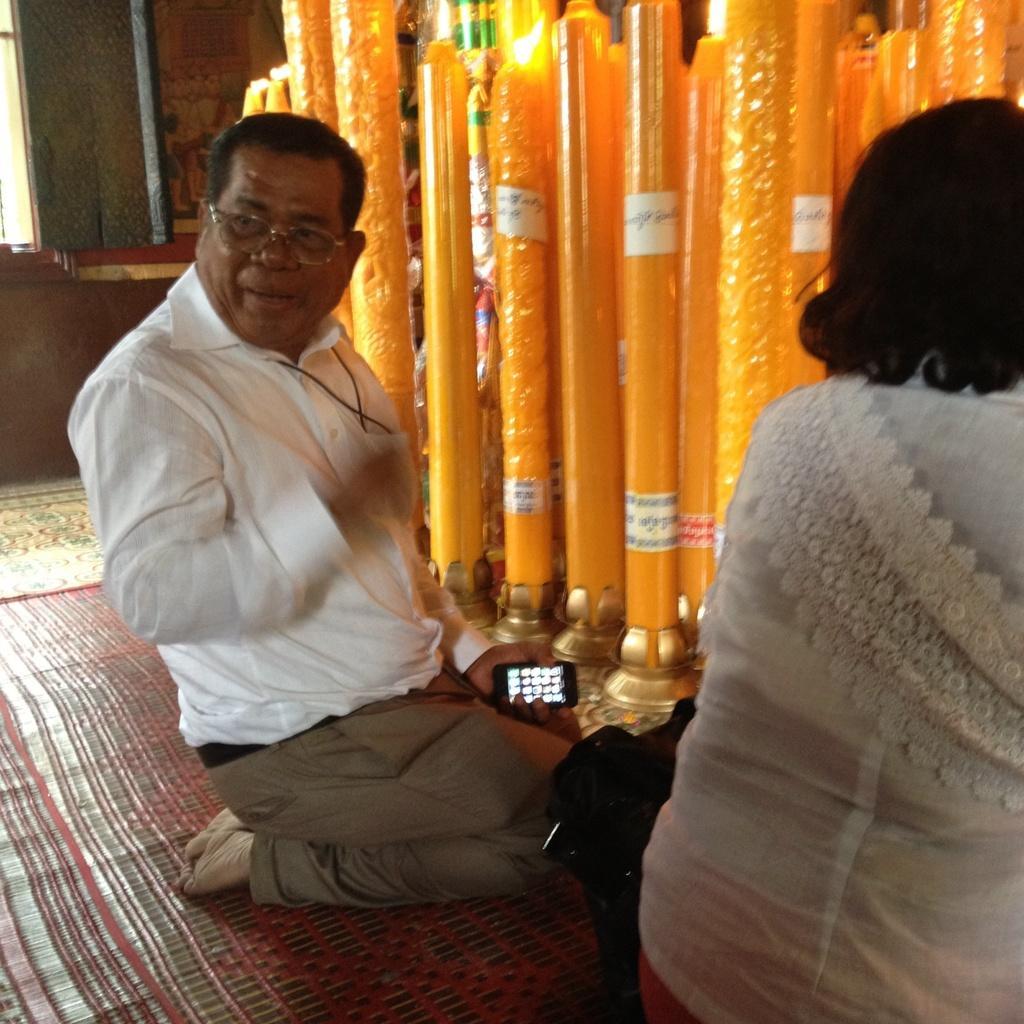Could you give a brief overview of what you see in this image? In this image we can see a person sitting on his knees holding a cellphone. We can also see a woman beside him. On the backside we can see some candles with flame on it. 